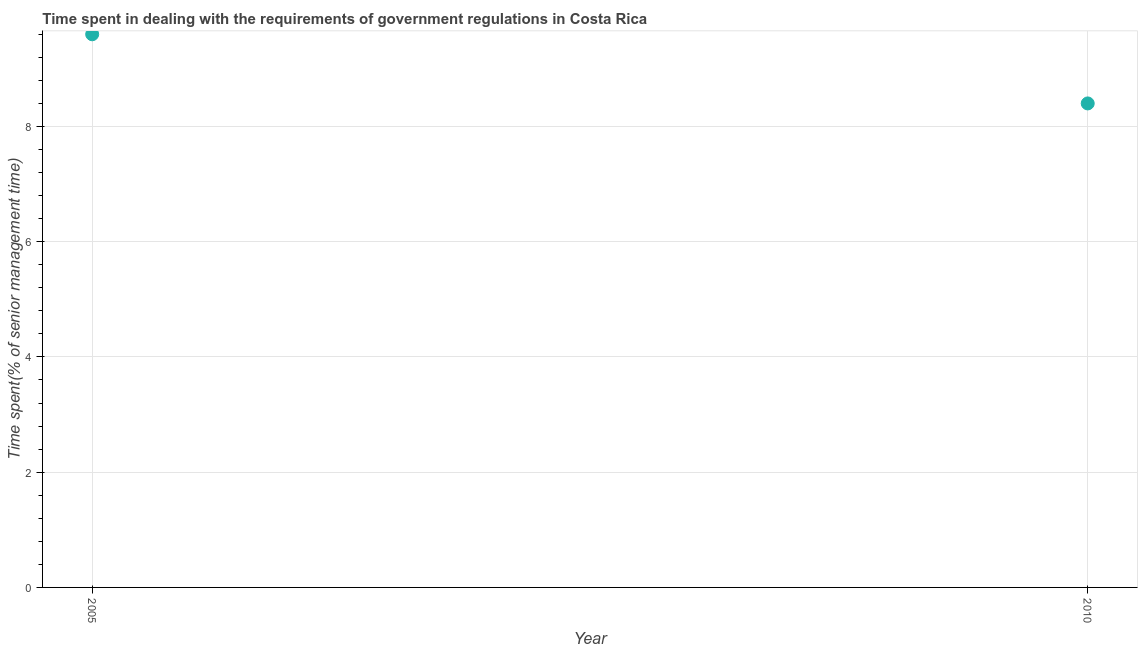Across all years, what is the maximum time spent in dealing with government regulations?
Your answer should be very brief. 9.6. In which year was the time spent in dealing with government regulations maximum?
Give a very brief answer. 2005. What is the sum of the time spent in dealing with government regulations?
Your answer should be very brief. 18. What is the difference between the time spent in dealing with government regulations in 2005 and 2010?
Provide a succinct answer. 1.2. What is the average time spent in dealing with government regulations per year?
Provide a short and direct response. 9. What is the median time spent in dealing with government regulations?
Provide a succinct answer. 9. Do a majority of the years between 2010 and 2005 (inclusive) have time spent in dealing with government regulations greater than 6.4 %?
Your response must be concise. No. What is the ratio of the time spent in dealing with government regulations in 2005 to that in 2010?
Your response must be concise. 1.14. Is the time spent in dealing with government regulations in 2005 less than that in 2010?
Provide a succinct answer. No. How many dotlines are there?
Keep it short and to the point. 1. Are the values on the major ticks of Y-axis written in scientific E-notation?
Ensure brevity in your answer.  No. Does the graph contain any zero values?
Provide a short and direct response. No. Does the graph contain grids?
Give a very brief answer. Yes. What is the title of the graph?
Give a very brief answer. Time spent in dealing with the requirements of government regulations in Costa Rica. What is the label or title of the X-axis?
Your response must be concise. Year. What is the label or title of the Y-axis?
Offer a terse response. Time spent(% of senior management time). What is the ratio of the Time spent(% of senior management time) in 2005 to that in 2010?
Make the answer very short. 1.14. 